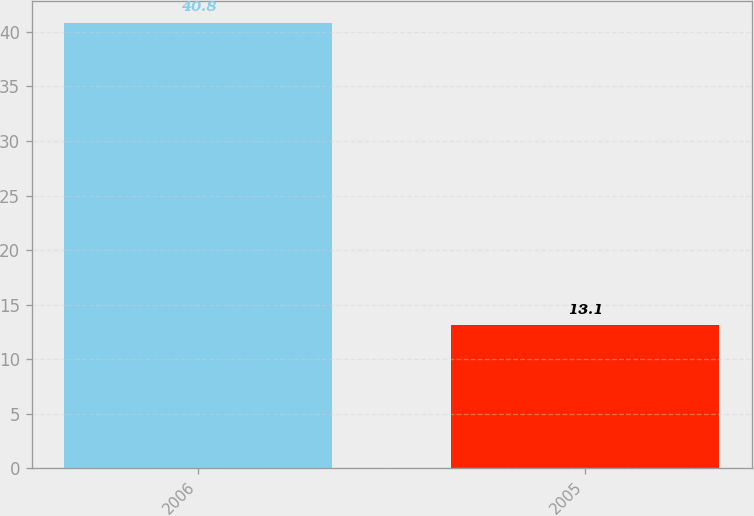Convert chart to OTSL. <chart><loc_0><loc_0><loc_500><loc_500><bar_chart><fcel>2006<fcel>2005<nl><fcel>40.8<fcel>13.1<nl></chart> 